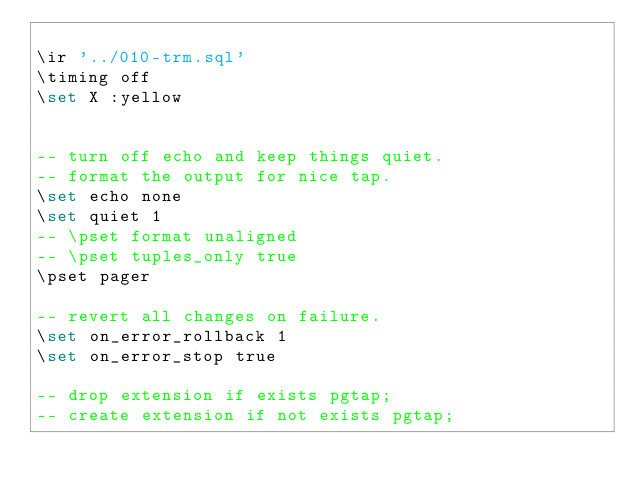Convert code to text. <code><loc_0><loc_0><loc_500><loc_500><_SQL_>
\ir '../010-trm.sql'
\timing off
\set X :yellow


-- turn off echo and keep things quiet.
-- format the output for nice tap.
\set echo none
\set quiet 1
-- \pset format unaligned
-- \pset tuples_only true
\pset pager

-- revert all changes on failure.
\set on_error_rollback 1
\set on_error_stop true

-- drop extension if exists pgtap;
-- create extension if not exists pgtap;
</code> 